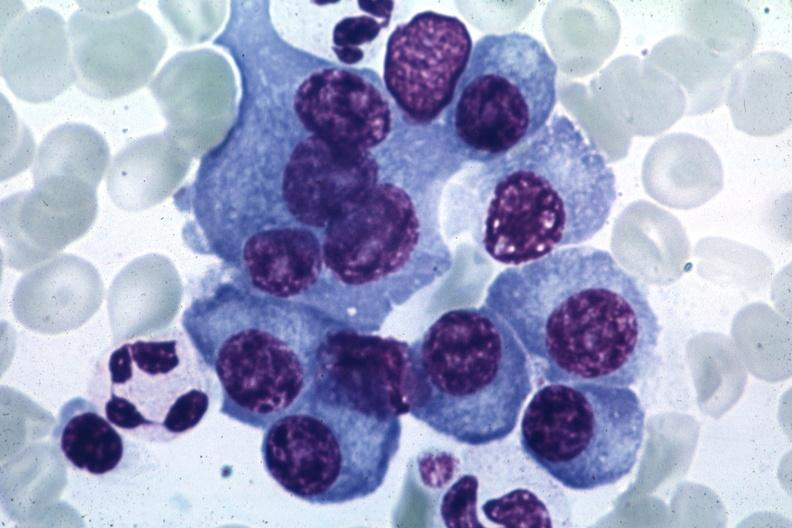what is present?
Answer the question using a single word or phrase. Plasma cell 